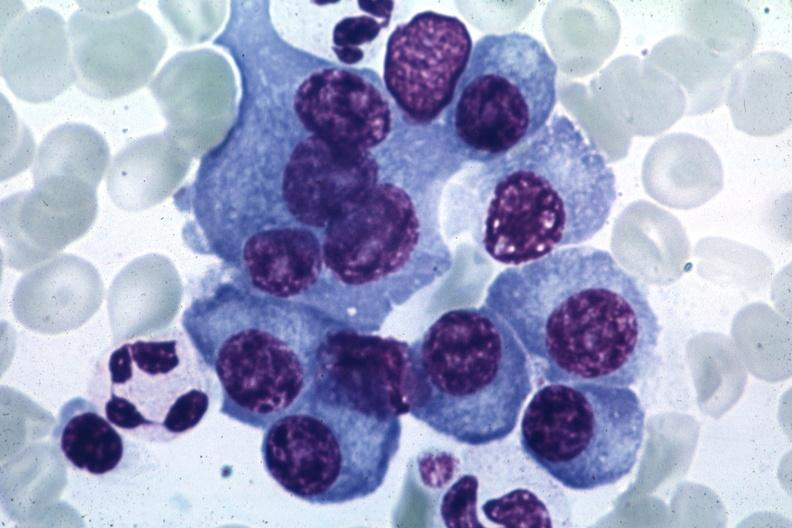what is present?
Answer the question using a single word or phrase. Plasma cell 